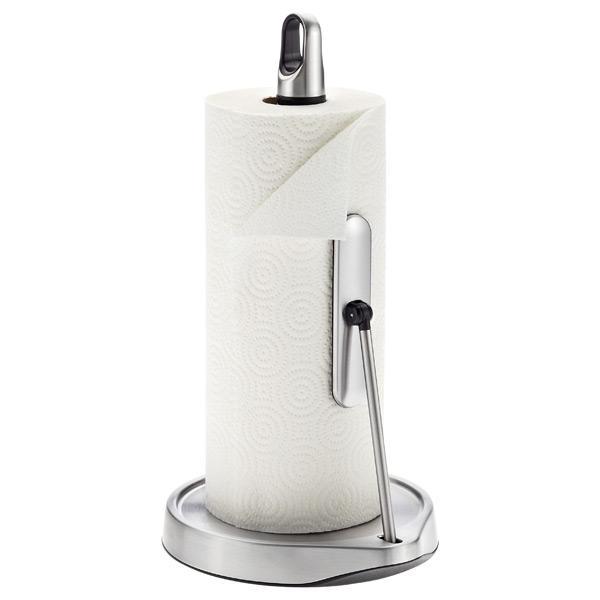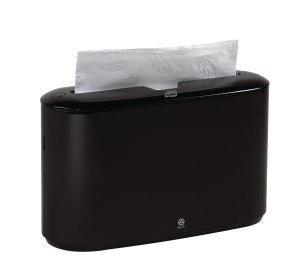The first image is the image on the left, the second image is the image on the right. Evaluate the accuracy of this statement regarding the images: "A paper is poking out of the dispenser in the image on the right.". Is it true? Answer yes or no. Yes. The first image is the image on the left, the second image is the image on the right. Evaluate the accuracy of this statement regarding the images: "Different style holders are shown in the left and right images, and the right image features an upright oblong opaque holder with a paper towel sticking out of its top.". Is it true? Answer yes or no. Yes. 